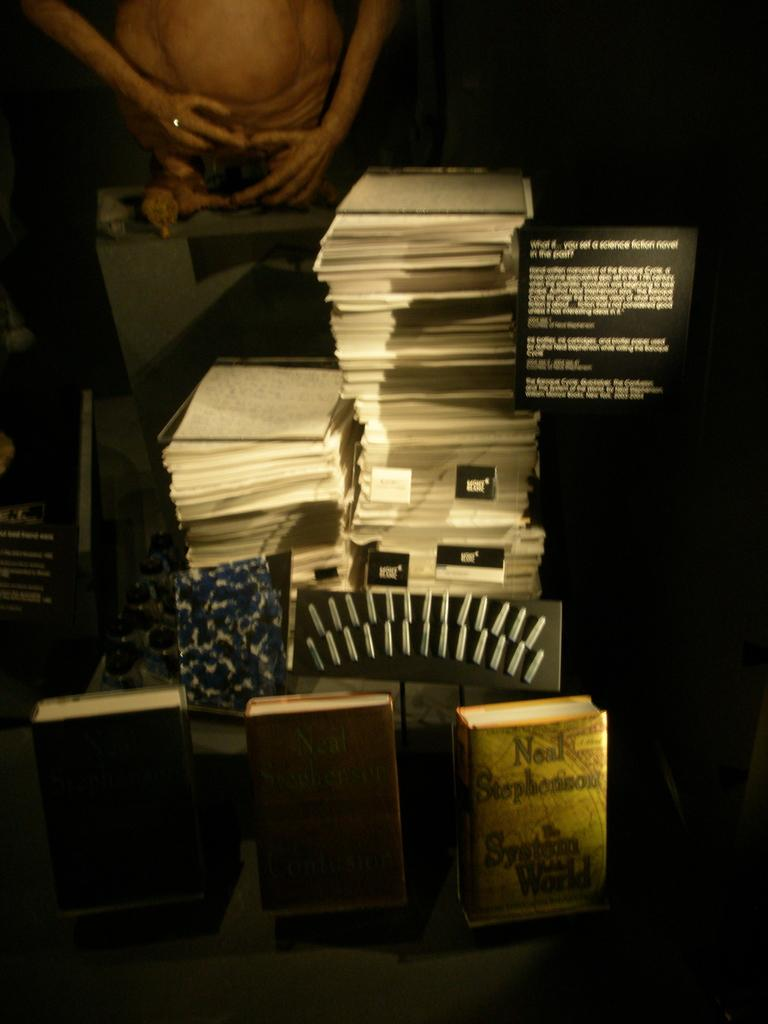Provide a one-sentence caption for the provided image. A sign reading "what if you set a science fiction novel in the past?" sits near a stack of papers. 